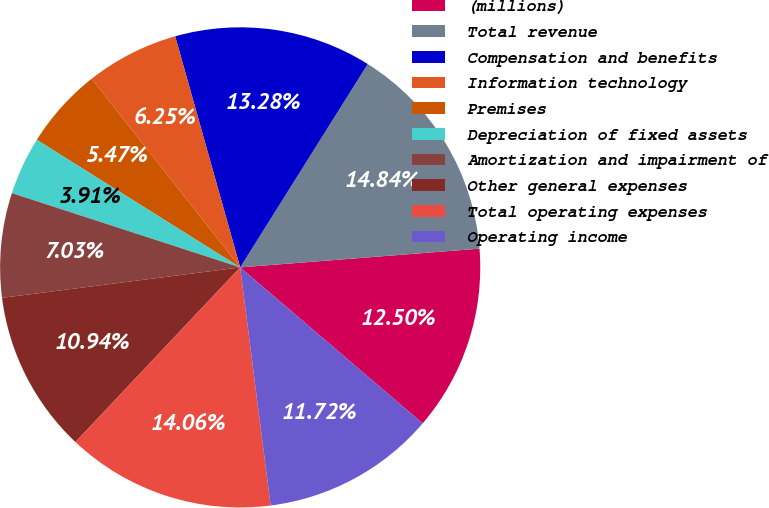Convert chart to OTSL. <chart><loc_0><loc_0><loc_500><loc_500><pie_chart><fcel>(millions)<fcel>Total revenue<fcel>Compensation and benefits<fcel>Information technology<fcel>Premises<fcel>Depreciation of fixed assets<fcel>Amortization and impairment of<fcel>Other general expenses<fcel>Total operating expenses<fcel>Operating income<nl><fcel>12.5%<fcel>14.84%<fcel>13.28%<fcel>6.25%<fcel>5.47%<fcel>3.91%<fcel>7.03%<fcel>10.94%<fcel>14.06%<fcel>11.72%<nl></chart> 